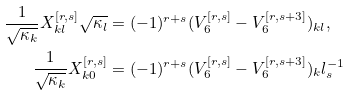Convert formula to latex. <formula><loc_0><loc_0><loc_500><loc_500>\frac { 1 } { \sqrt { \kappa _ { k } } } X _ { k l } ^ { [ r , s ] } \sqrt { \kappa _ { l } } & = ( - 1 ) ^ { r + s } ( V _ { 6 } ^ { [ r , s ] } - V _ { 6 } ^ { [ r , s + 3 ] } ) _ { k l } , \\ \frac { 1 } { \sqrt { \kappa _ { k } } } X _ { k 0 } ^ { [ r , s ] } & = ( - 1 ) ^ { r + s } ( V _ { 6 } ^ { [ r , s ] } - V _ { 6 } ^ { [ r , s + 3 ] } ) _ { k } l _ { s } ^ { - 1 }</formula> 